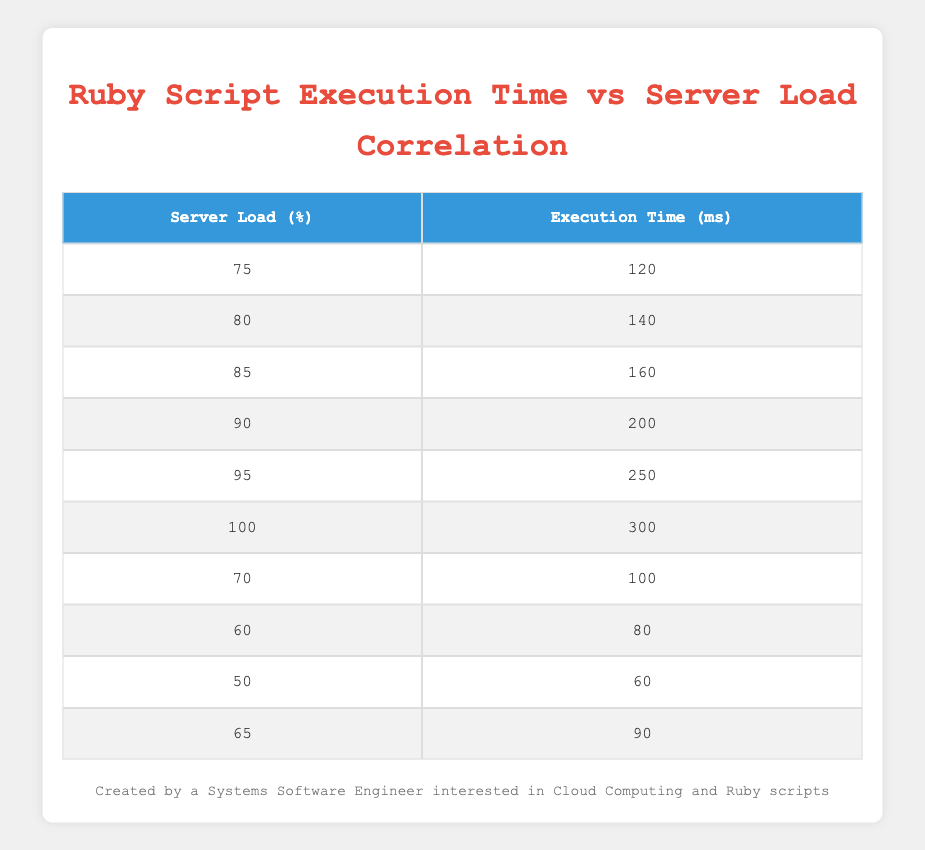What is the execution time when the server load is at 90%? According to the table, when the server load is 90%, the execution time is 200 milliseconds.
Answer: 200 What is the highest execution time recorded in the table? The highest execution time can be found by looking through the execution times. The maximum execution time listed is 300 milliseconds at 100% server load.
Answer: 300 What is the execution time for a server load of 60%? Referencing the table, when the server load is 60%, the execution time is 80 milliseconds.
Answer: 80 Is there any execution time that is less than 100 milliseconds? By analyzing the table, we see that the execution times below 100 milliseconds are 60 ms, 80 ms, and 100 ms. Thus, there are execution times less than 100 milliseconds.
Answer: Yes What is the average execution time for server loads from 70% to 95%? To compute the average for server loads 70%, 75%, 80%, 85%, 90%, and 95%, we sum their execution times (100 + 120 + 140 + 160 + 200 + 250 = 970) and then divide by the number of points (6). Thus, 970 / 6 = 161.67 milliseconds.
Answer: 161.67 How much does the execution time increase from a server load of 75% to 100%? The execution time at 75% is 120 ms and at 100% is 300 ms. The increase is calculated as 300 - 120 = 180 ms.
Answer: 180 What is the execution time difference between a server load of 80% and a server load of 70%? Referring to the table, the execution time at 80% server load is 140 ms and at 70% is 100 ms. The difference is 140 - 100 = 40 ms.
Answer: 40 Which server load results in an execution time of 250 ms? The observation of the table shows that an execution time of 250 ms corresponds to a server load of 95%.
Answer: 95% Is the execution time at 65% greater than the execution time at 60%? Checking the execution times, at 65% server load the execution time is 90 ms and for 60% it is 80 ms. Since 90 ms is greater than 80 ms, the answer is yes.
Answer: Yes 